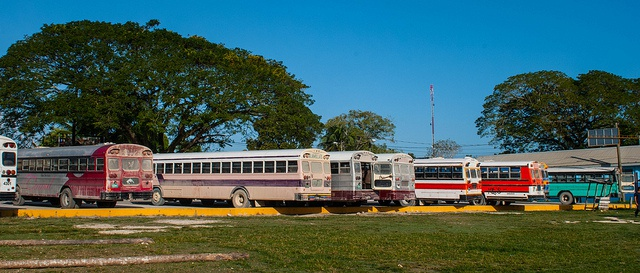Describe the objects in this image and their specific colors. I can see bus in teal, tan, black, lightgray, and gray tones, bus in teal, gray, black, brown, and maroon tones, bus in teal, black, lightgray, gray, and darkgray tones, bus in teal, black, gray, darkgray, and lightgray tones, and bus in teal, black, red, lightgray, and gray tones in this image. 